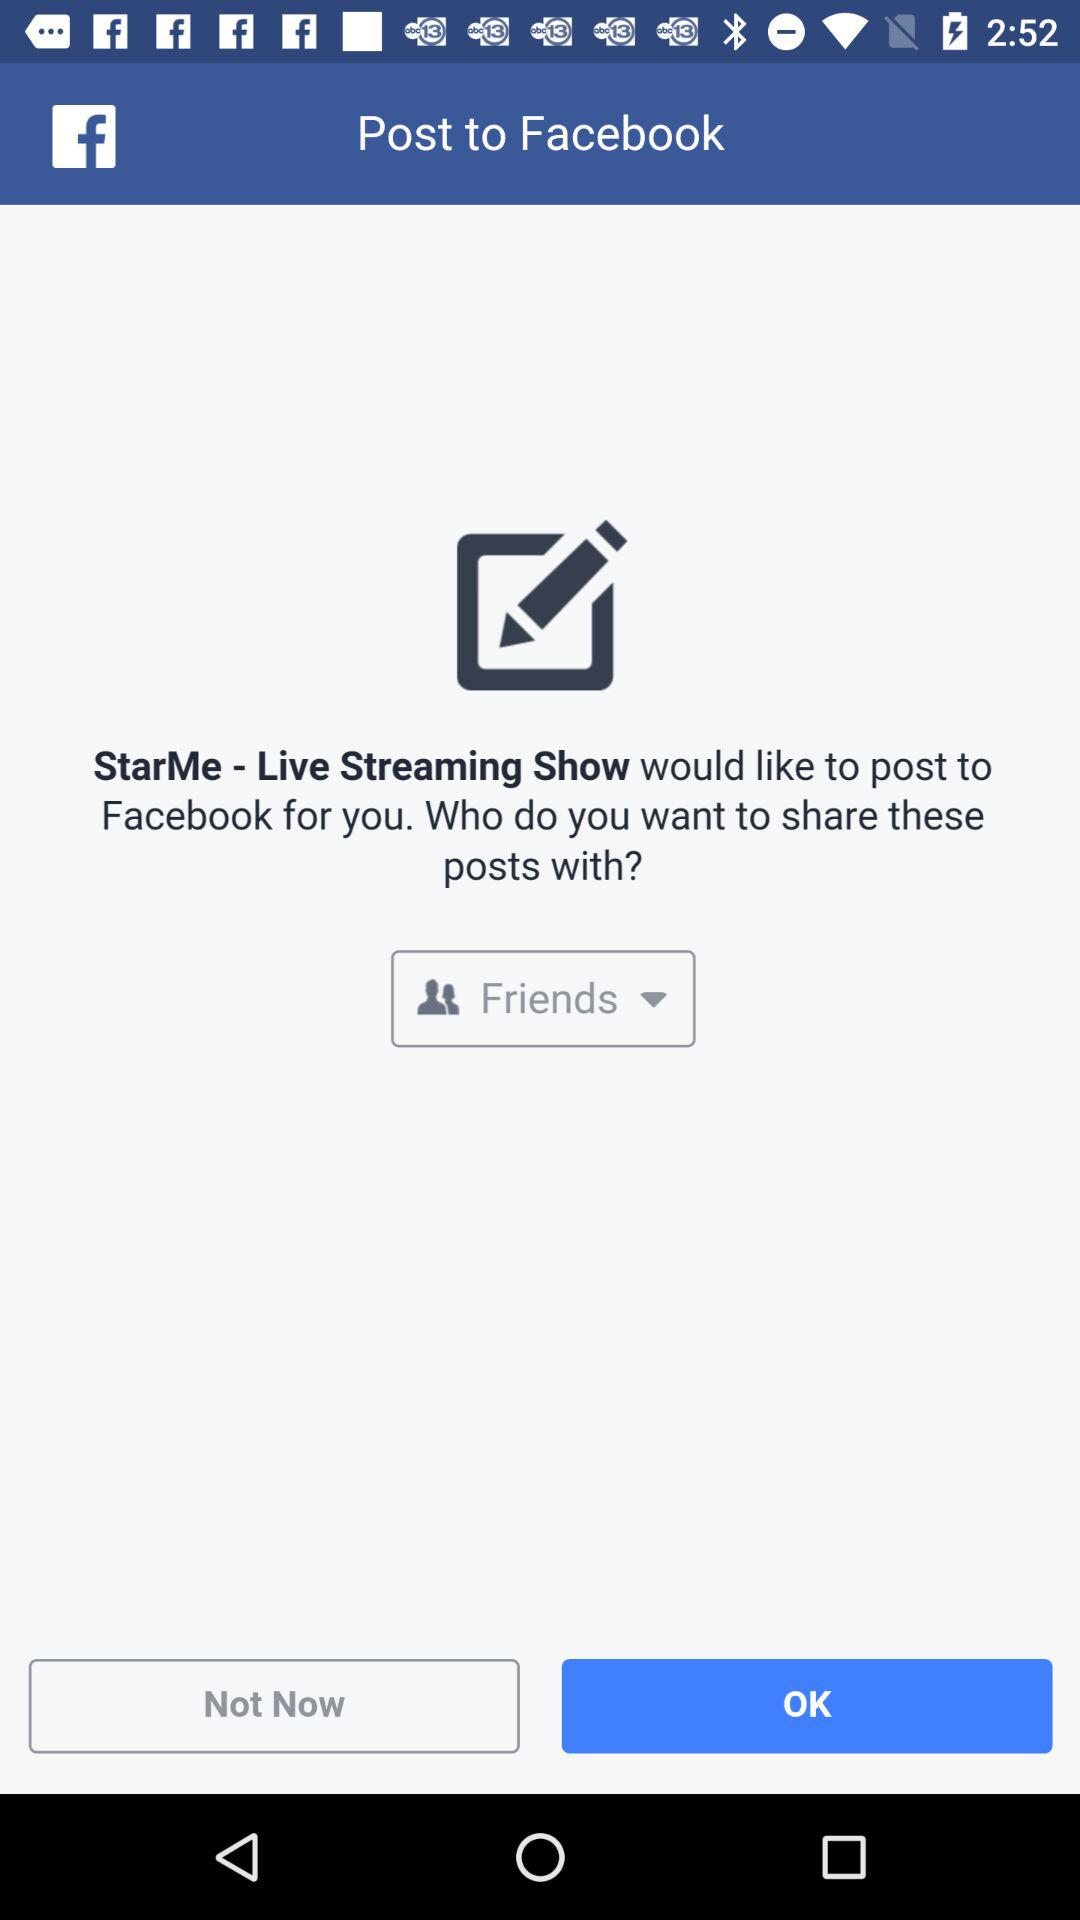What is the application name? The application name is "Facebook". 